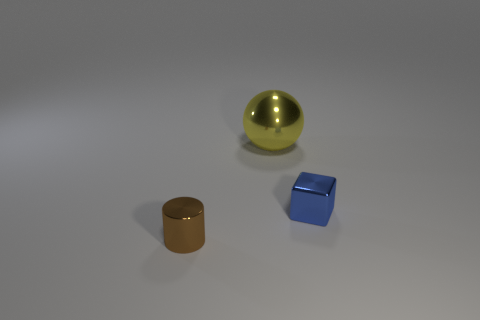Is the number of blue metal things on the right side of the tiny shiny cube less than the number of cyan objects?
Keep it short and to the point. No. Is there another ball that has the same size as the metallic ball?
Keep it short and to the point. No. How many things are behind the object right of the big metallic object?
Your response must be concise. 1. There is a small thing behind the metal object that is in front of the blue metallic object; what is its color?
Provide a succinct answer. Blue. Are there any other small metallic things of the same shape as the brown metal thing?
Offer a terse response. No. There is a tiny object to the right of the shiny cylinder; is it the same shape as the tiny brown object?
Your answer should be very brief. No. How many shiny things are both in front of the small blue block and on the right side of the big yellow shiny thing?
Provide a succinct answer. 0. What is the shape of the yellow metallic object that is behind the blue block?
Offer a very short reply. Sphere. What number of small cubes are made of the same material as the yellow sphere?
Your response must be concise. 1. There is a large shiny object; is it the same shape as the tiny metallic object that is to the left of the small blue shiny cube?
Provide a succinct answer. No. 